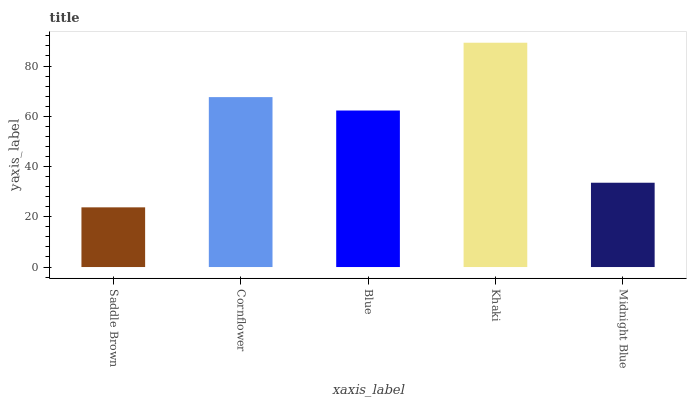Is Saddle Brown the minimum?
Answer yes or no. Yes. Is Khaki the maximum?
Answer yes or no. Yes. Is Cornflower the minimum?
Answer yes or no. No. Is Cornflower the maximum?
Answer yes or no. No. Is Cornflower greater than Saddle Brown?
Answer yes or no. Yes. Is Saddle Brown less than Cornflower?
Answer yes or no. Yes. Is Saddle Brown greater than Cornflower?
Answer yes or no. No. Is Cornflower less than Saddle Brown?
Answer yes or no. No. Is Blue the high median?
Answer yes or no. Yes. Is Blue the low median?
Answer yes or no. Yes. Is Khaki the high median?
Answer yes or no. No. Is Cornflower the low median?
Answer yes or no. No. 